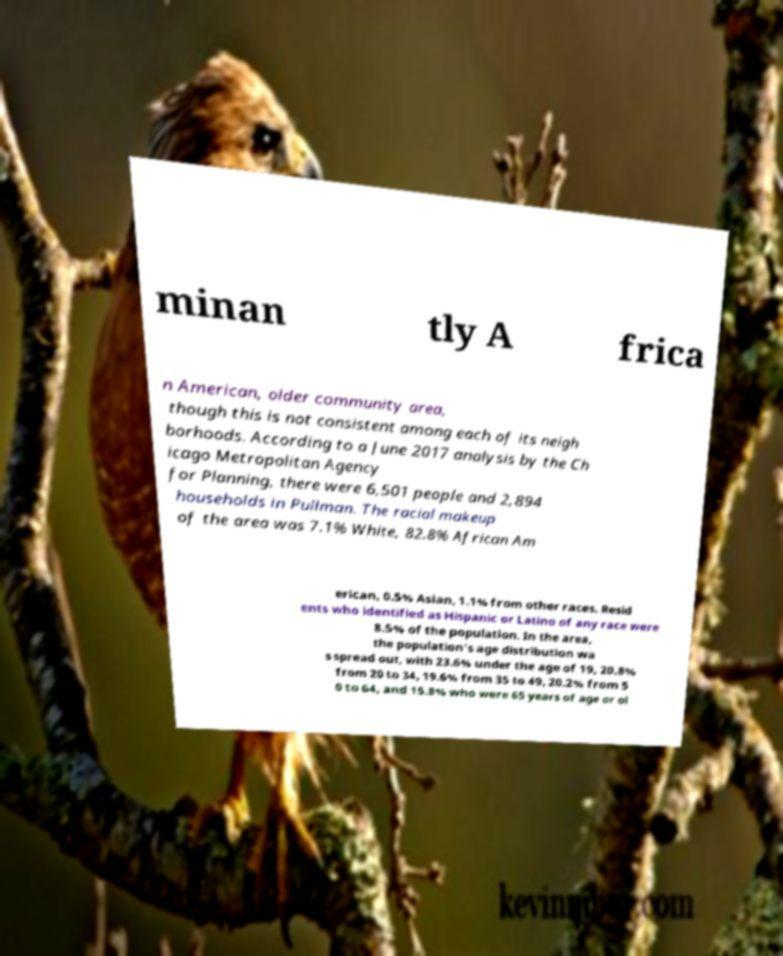Can you accurately transcribe the text from the provided image for me? minan tly A frica n American, older community area, though this is not consistent among each of its neigh borhoods. According to a June 2017 analysis by the Ch icago Metropolitan Agency for Planning, there were 6,501 people and 2,894 households in Pullman. The racial makeup of the area was 7.1% White, 82.8% African Am erican, 0.5% Asian, 1.1% from other races. Resid ents who identified as Hispanic or Latino of any race were 8.5% of the population. In the area, the population's age distribution wa s spread out, with 23.6% under the age of 19, 20.8% from 20 to 34, 19.6% from 35 to 49, 20.2% from 5 0 to 64, and 15.8% who were 65 years of age or ol 